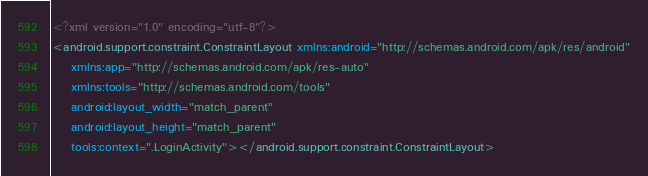<code> <loc_0><loc_0><loc_500><loc_500><_XML_><?xml version="1.0" encoding="utf-8"?>
<android.support.constraint.ConstraintLayout xmlns:android="http://schemas.android.com/apk/res/android"
    xmlns:app="http://schemas.android.com/apk/res-auto"
    xmlns:tools="http://schemas.android.com/tools"
    android:layout_width="match_parent"
    android:layout_height="match_parent"
    tools:context=".LoginActivity"></android.support.constraint.ConstraintLayout></code> 